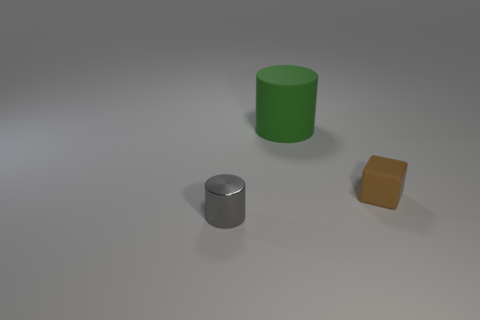Add 2 metal cylinders. How many objects exist? 5 Subtract all blocks. How many objects are left? 2 Subtract 0 purple balls. How many objects are left? 3 Subtract all brown metal objects. Subtract all gray metal objects. How many objects are left? 2 Add 2 metal things. How many metal things are left? 3 Add 1 cyan shiny cubes. How many cyan shiny cubes exist? 1 